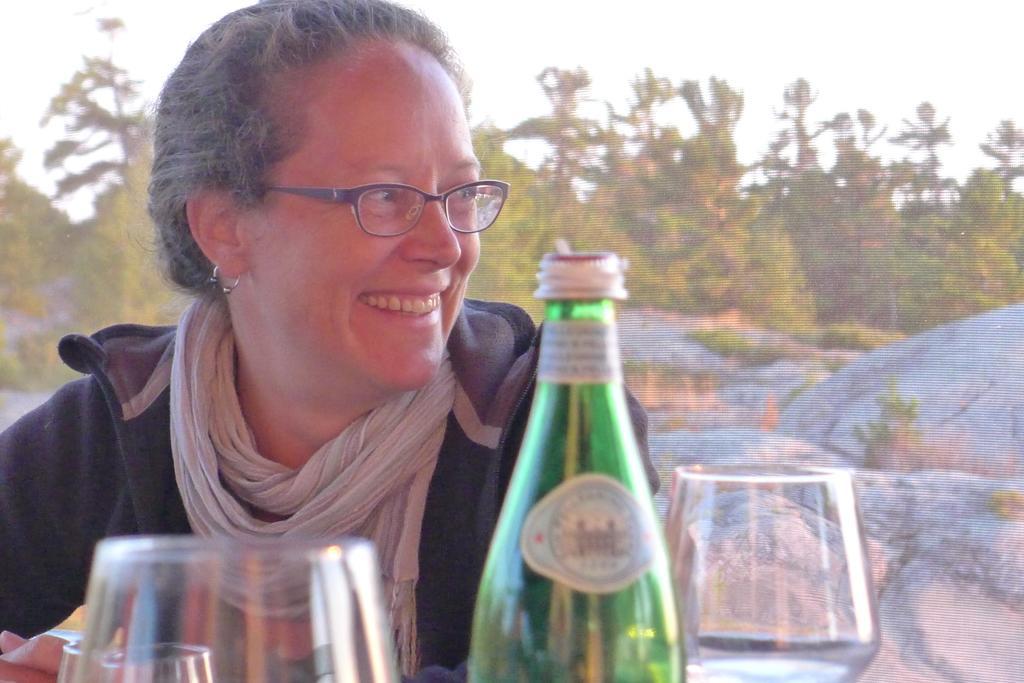Describe this image in one or two sentences. Background is blurry. We can see sky, trees and rocks. Here we can see a woman wearing spectacles and she is carrying a pretty smile on her face. On the table we can see glasses and a bottle in green colour. 